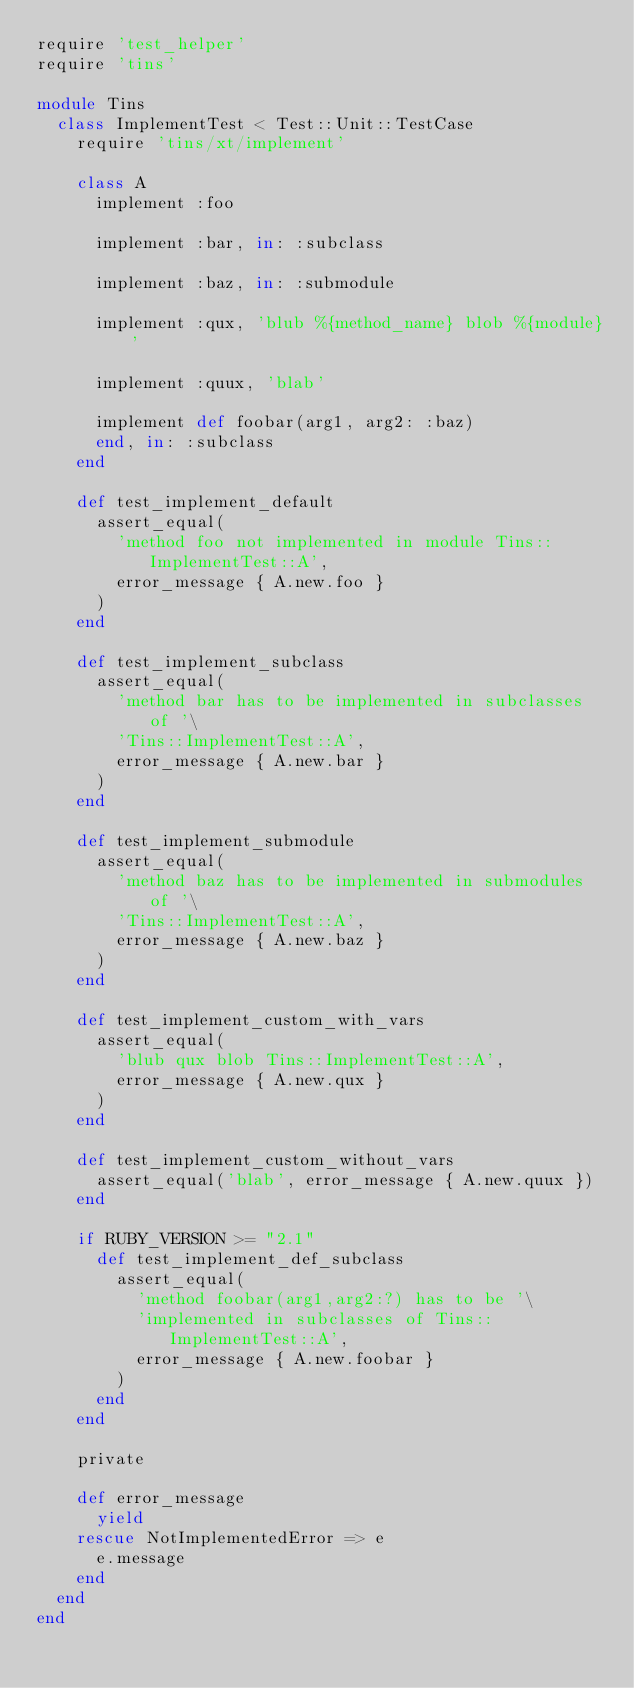Convert code to text. <code><loc_0><loc_0><loc_500><loc_500><_Ruby_>require 'test_helper'
require 'tins'

module Tins
  class ImplementTest < Test::Unit::TestCase
    require 'tins/xt/implement'

    class A
      implement :foo

      implement :bar, in: :subclass

      implement :baz, in: :submodule

      implement :qux, 'blub %{method_name} blob %{module}'

      implement :quux, 'blab'

      implement def foobar(arg1, arg2: :baz)
      end, in: :subclass
    end

    def test_implement_default
      assert_equal(
        'method foo not implemented in module Tins::ImplementTest::A',
        error_message { A.new.foo }
      )
    end

    def test_implement_subclass
      assert_equal(
        'method bar has to be implemented in subclasses of '\
        'Tins::ImplementTest::A',
        error_message { A.new.bar }
      )
    end

    def test_implement_submodule
      assert_equal(
        'method baz has to be implemented in submodules of '\
        'Tins::ImplementTest::A',
        error_message { A.new.baz }
      )
    end

    def test_implement_custom_with_vars
      assert_equal(
        'blub qux blob Tins::ImplementTest::A',
        error_message { A.new.qux }
      )
    end

    def test_implement_custom_without_vars
      assert_equal('blab', error_message { A.new.quux })
    end

    if RUBY_VERSION >= "2.1"
      def test_implement_def_subclass
        assert_equal(
          'method foobar(arg1,arg2:?) has to be '\
          'implemented in subclasses of Tins::ImplementTest::A',
          error_message { A.new.foobar }
        )
      end
    end

    private

    def error_message
      yield
    rescue NotImplementedError => e
      e.message
    end
  end
end
</code> 